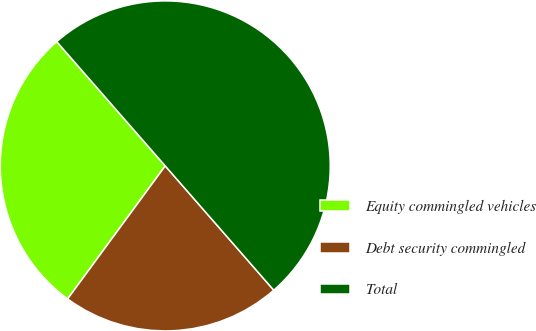<chart> <loc_0><loc_0><loc_500><loc_500><pie_chart><fcel>Equity commingled vehicles<fcel>Debt security commingled<fcel>Total<nl><fcel>28.5%<fcel>21.5%<fcel>50.0%<nl></chart> 